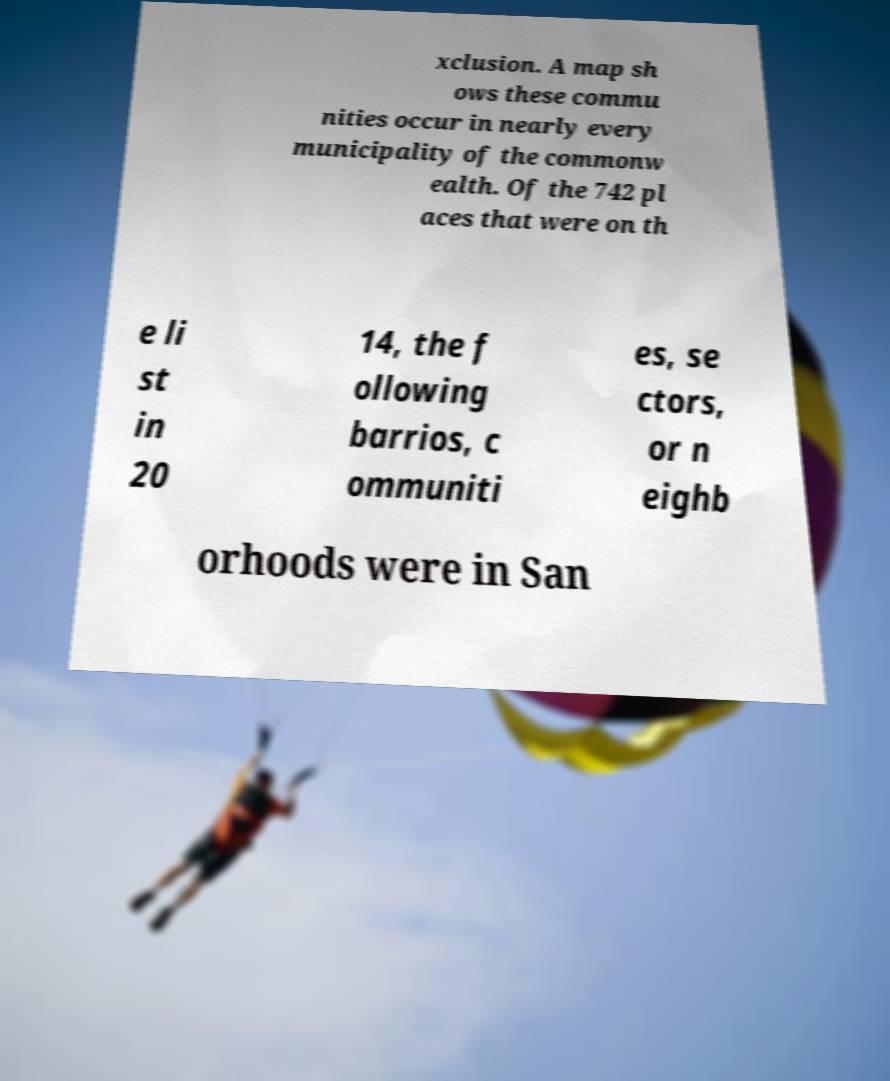Please identify and transcribe the text found in this image. xclusion. A map sh ows these commu nities occur in nearly every municipality of the commonw ealth. Of the 742 pl aces that were on th e li st in 20 14, the f ollowing barrios, c ommuniti es, se ctors, or n eighb orhoods were in San 